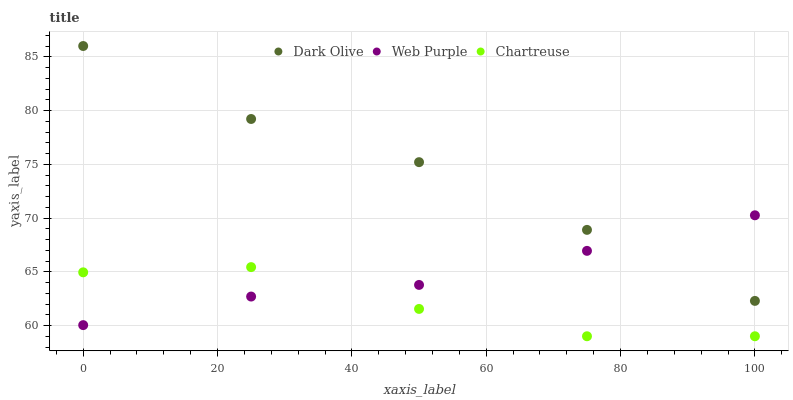Does Chartreuse have the minimum area under the curve?
Answer yes or no. Yes. Does Dark Olive have the maximum area under the curve?
Answer yes or no. Yes. Does Dark Olive have the minimum area under the curve?
Answer yes or no. No. Does Chartreuse have the maximum area under the curve?
Answer yes or no. No. Is Web Purple the smoothest?
Answer yes or no. Yes. Is Chartreuse the roughest?
Answer yes or no. Yes. Is Dark Olive the smoothest?
Answer yes or no. No. Is Dark Olive the roughest?
Answer yes or no. No. Does Chartreuse have the lowest value?
Answer yes or no. Yes. Does Dark Olive have the lowest value?
Answer yes or no. No. Does Dark Olive have the highest value?
Answer yes or no. Yes. Does Chartreuse have the highest value?
Answer yes or no. No. Is Chartreuse less than Dark Olive?
Answer yes or no. Yes. Is Dark Olive greater than Chartreuse?
Answer yes or no. Yes. Does Dark Olive intersect Web Purple?
Answer yes or no. Yes. Is Dark Olive less than Web Purple?
Answer yes or no. No. Is Dark Olive greater than Web Purple?
Answer yes or no. No. Does Chartreuse intersect Dark Olive?
Answer yes or no. No. 